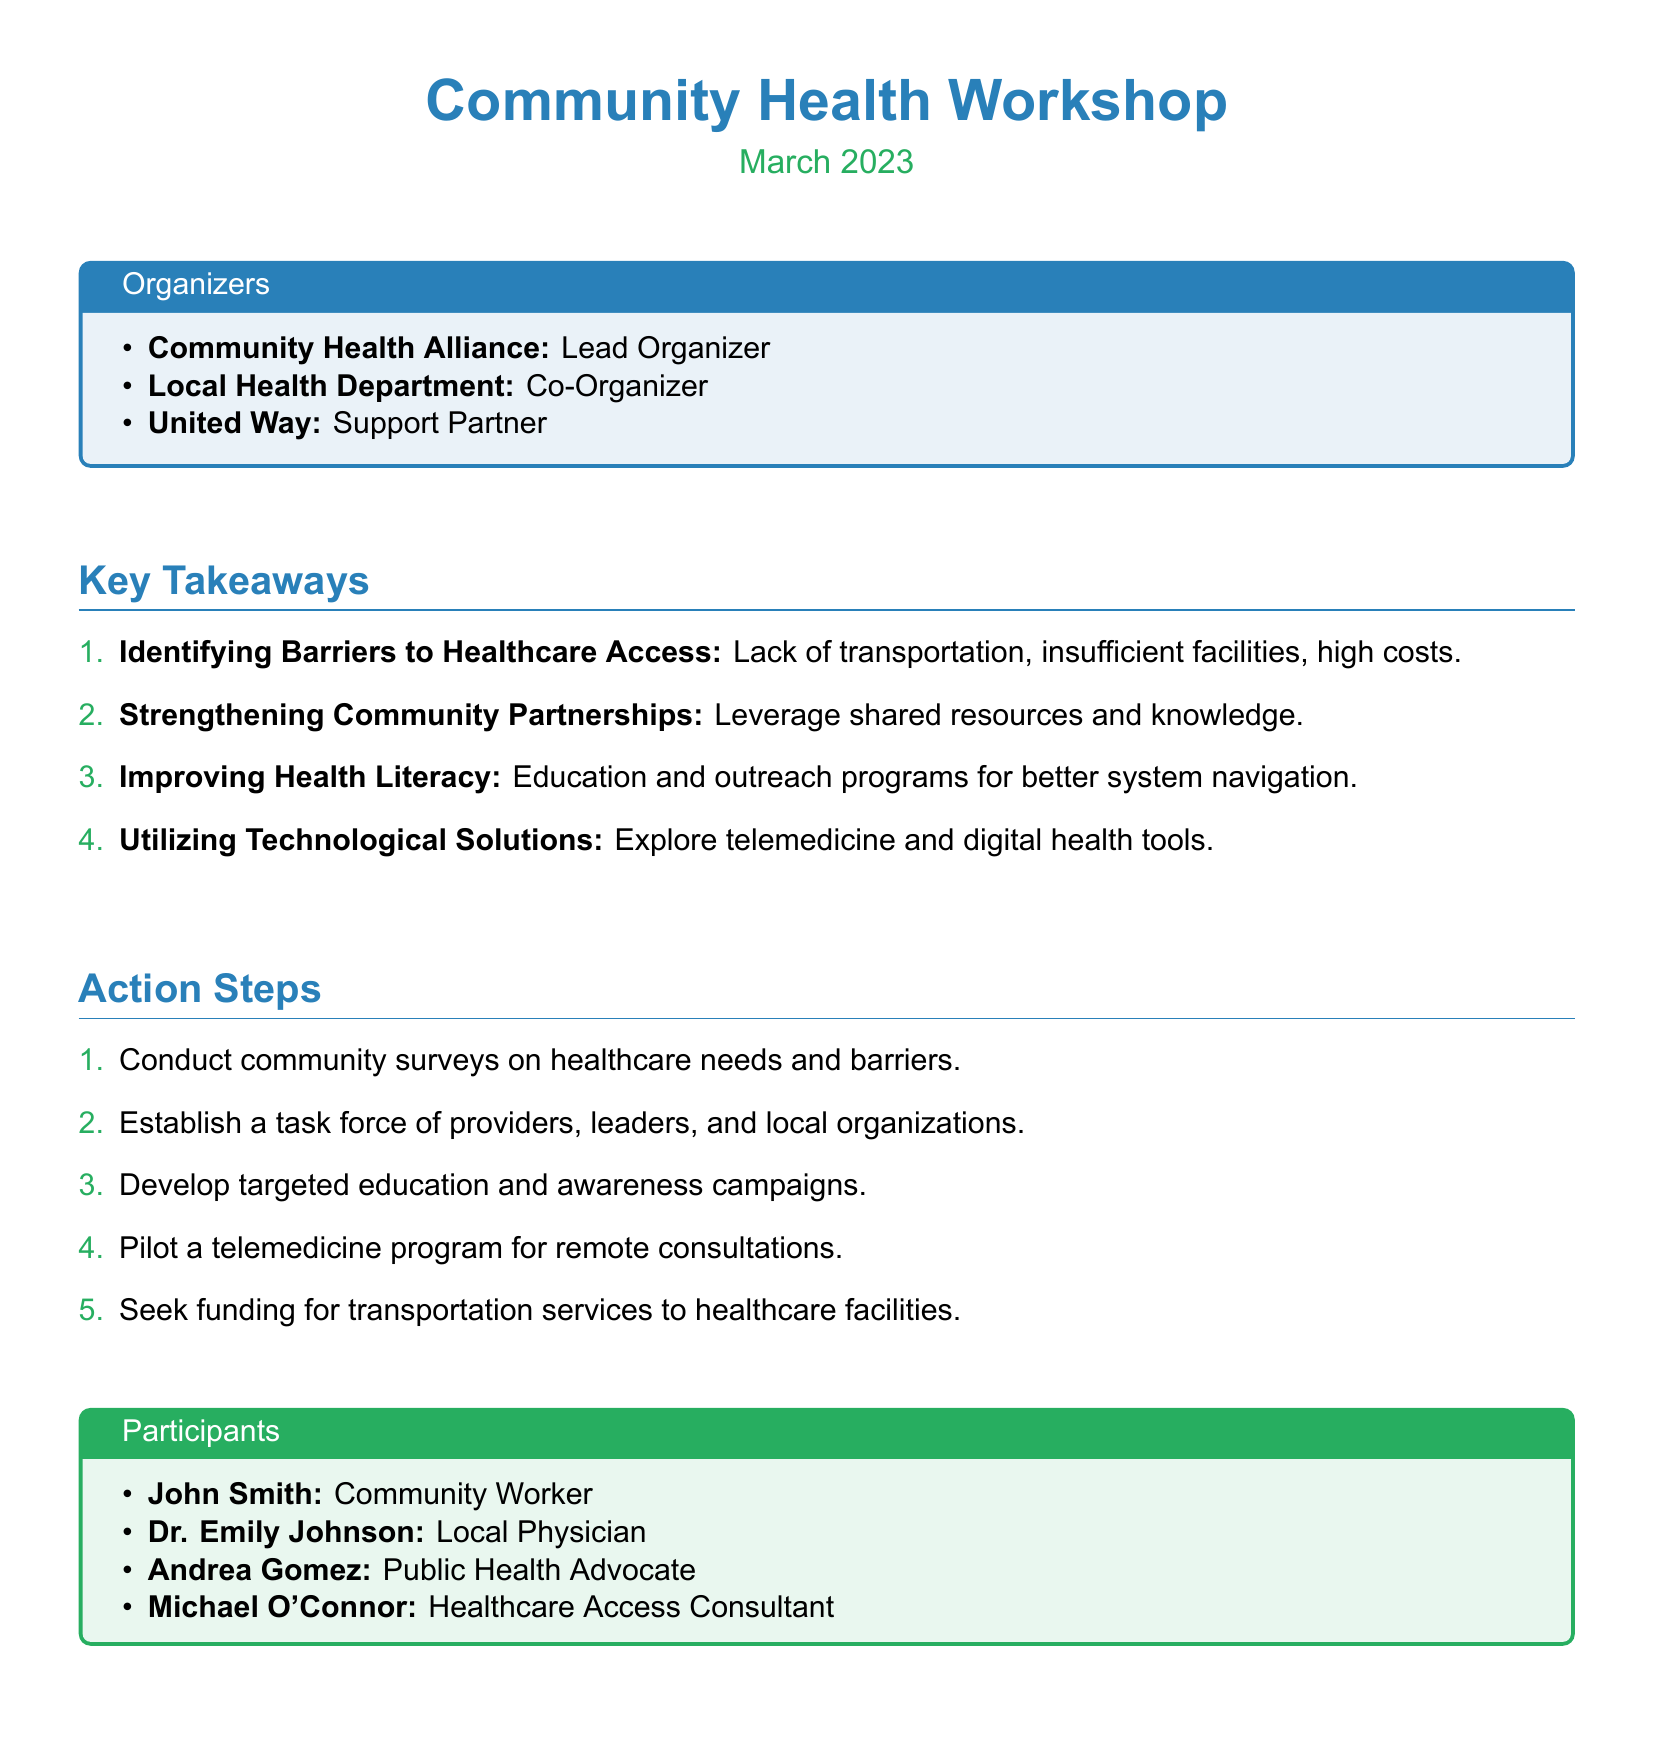What was the date of the Community Health Workshop? The date of the workshop is mentioned in the document header.
Answer: March 2023 Who was the lead organizer of the workshop? The document lists the organizers at the beginning, indicating the lead organizer.
Answer: Community Health Alliance What is one identified barrier to healthcare access? The key takeaways section lists barriers to healthcare access.
Answer: Lack of transportation How many action steps are proposed in the document? The action steps section enumerates the steps to be taken for improving healthcare access.
Answer: Five Who is one participant listed from the workshop? The participants section provides names of individuals involved in the workshop.
Answer: John Smith What is one proposed technological solution mentioned in the key takeaways? The key takeaways include various solutions for improving healthcare access.
Answer: Telemedicine What is the purpose of the proposed community surveys? The action steps outline multiple strategies for enhancing healthcare access.
Answer: Conduct community surveys on healthcare needs and barriers Name one organization that supported the workshop. The document specifies the roles of different organizations involved in the workshop.
Answer: United Way 